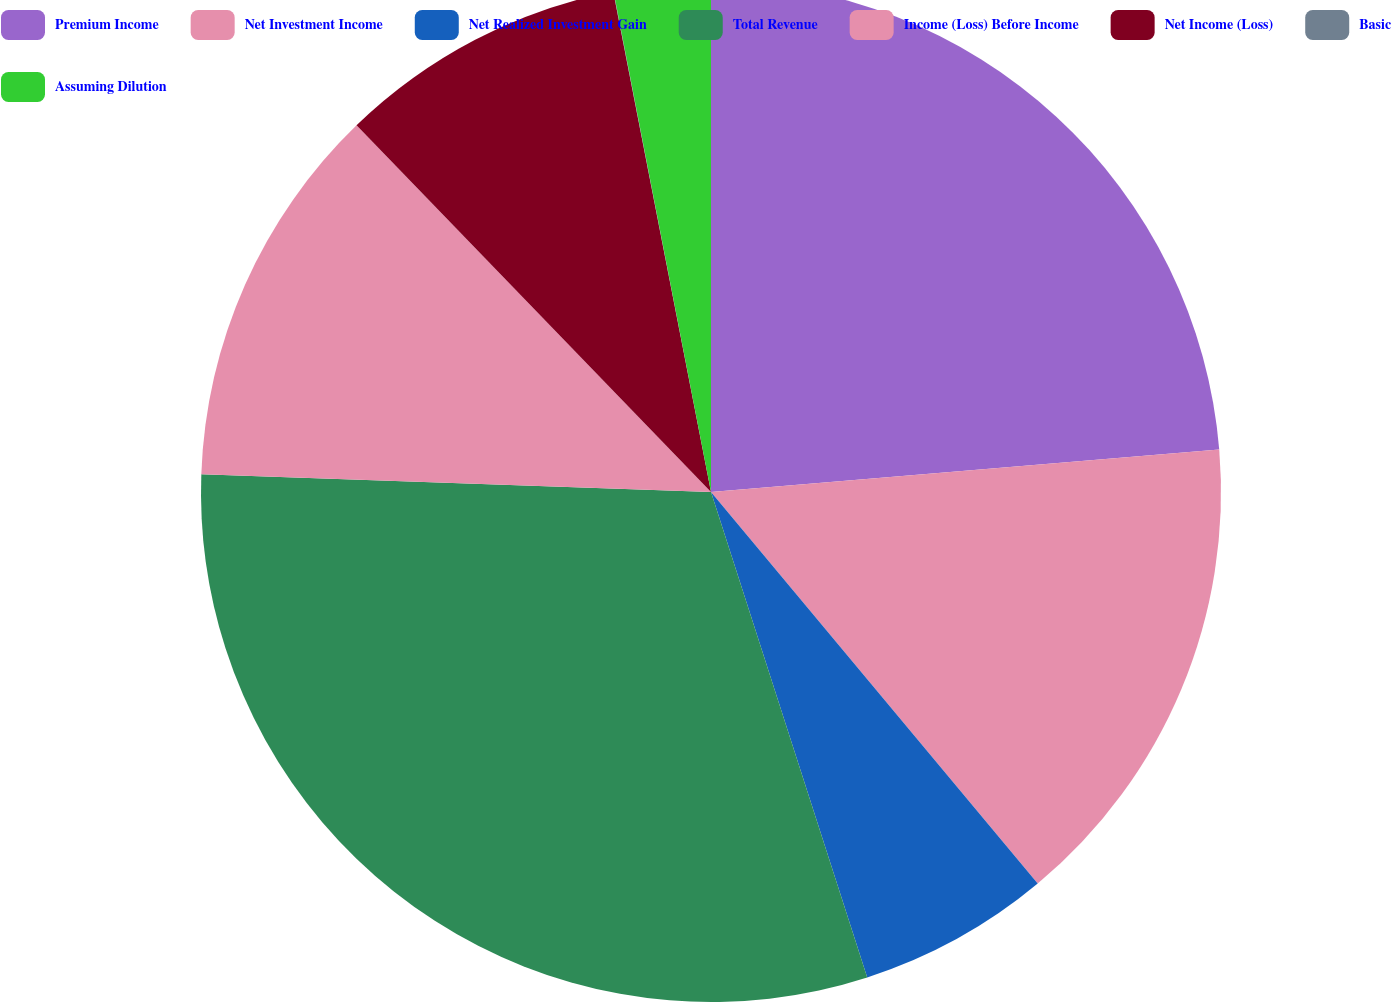<chart> <loc_0><loc_0><loc_500><loc_500><pie_chart><fcel>Premium Income<fcel>Net Investment Income<fcel>Net Realized Investment Gain<fcel>Total Revenue<fcel>Income (Loss) Before Income<fcel>Net Income (Loss)<fcel>Basic<fcel>Assuming Dilution<nl><fcel>23.67%<fcel>15.26%<fcel>6.11%<fcel>30.51%<fcel>12.21%<fcel>9.16%<fcel>0.01%<fcel>3.06%<nl></chart> 